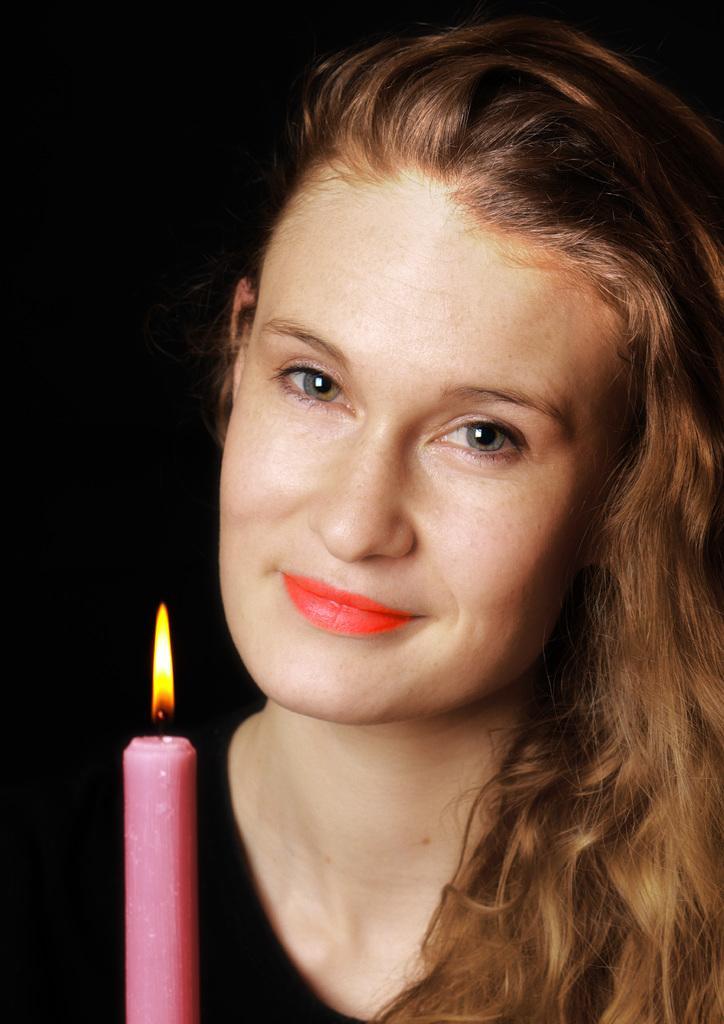How would you summarize this image in a sentence or two? In this image there is a person truncated towards the right of the image, there is a candle truncated towards the bottom of the image, there is fire, the background of the image is dark. 